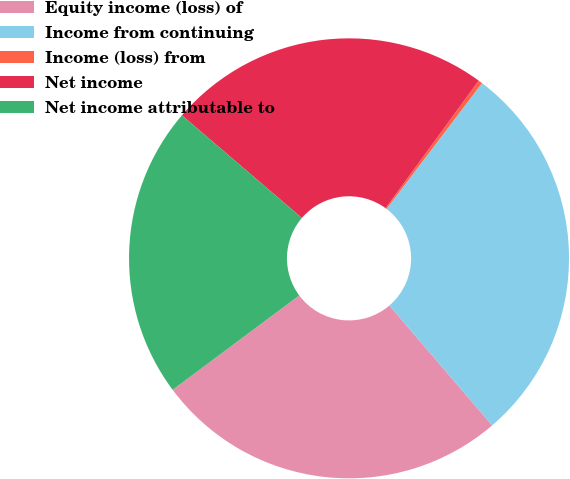Convert chart. <chart><loc_0><loc_0><loc_500><loc_500><pie_chart><fcel>Equity income (loss) of<fcel>Income from continuing<fcel>Income (loss) from<fcel>Net income<fcel>Net income attributable to<nl><fcel>26.08%<fcel>28.39%<fcel>0.3%<fcel>23.77%<fcel>21.46%<nl></chart> 